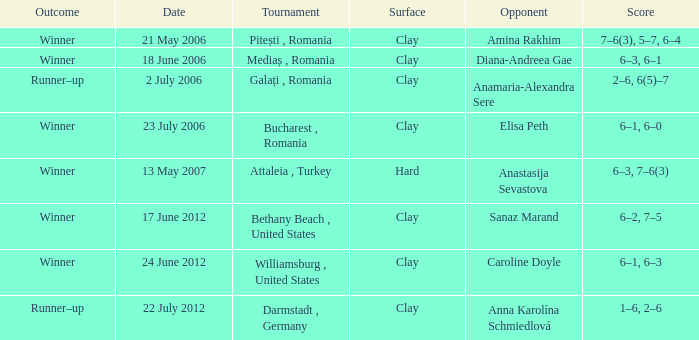On may 21, 2006, what event was conducted? Pitești , Romania. 